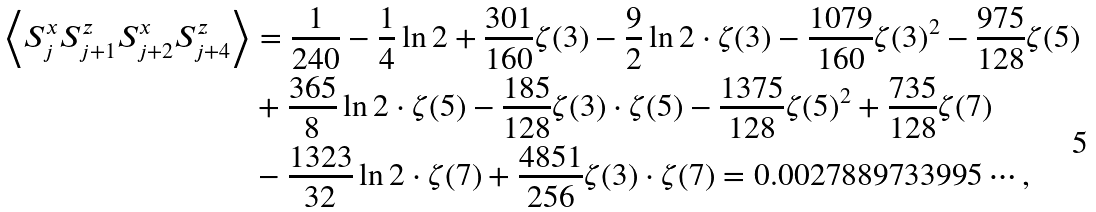<formula> <loc_0><loc_0><loc_500><loc_500>\left \langle S _ { j } ^ { x } S _ { j + 1 } ^ { z } S _ { j + 2 } ^ { x } S _ { j + 4 } ^ { z } \right \rangle & = \frac { 1 } { 2 4 0 } - \frac { 1 } { 4 } \ln 2 + \frac { 3 0 1 } { 1 6 0 } \zeta ( 3 ) - \frac { 9 } { 2 } \ln 2 \cdot \zeta ( 3 ) - \frac { 1 0 7 9 } { 1 6 0 } \zeta ( 3 ) ^ { 2 } - \frac { 9 7 5 } { 1 2 8 } \zeta ( 5 ) \\ & + \frac { 3 6 5 } { 8 } \ln 2 \cdot \zeta ( 5 ) - \frac { 1 8 5 } { 1 2 8 } \zeta ( 3 ) \cdot \zeta ( 5 ) - \frac { 1 3 7 5 } { 1 2 8 } \zeta ( 5 ) ^ { 2 } + \frac { 7 3 5 } { 1 2 8 } \zeta ( 7 ) \\ & - \frac { 1 3 2 3 } { 3 2 } \ln 2 \cdot \zeta ( 7 ) + \frac { 4 8 5 1 } { 2 5 6 } \zeta ( 3 ) \cdot \zeta ( 7 ) = 0 . 0 0 2 7 8 8 9 7 3 3 9 9 5 \cdots ,</formula> 